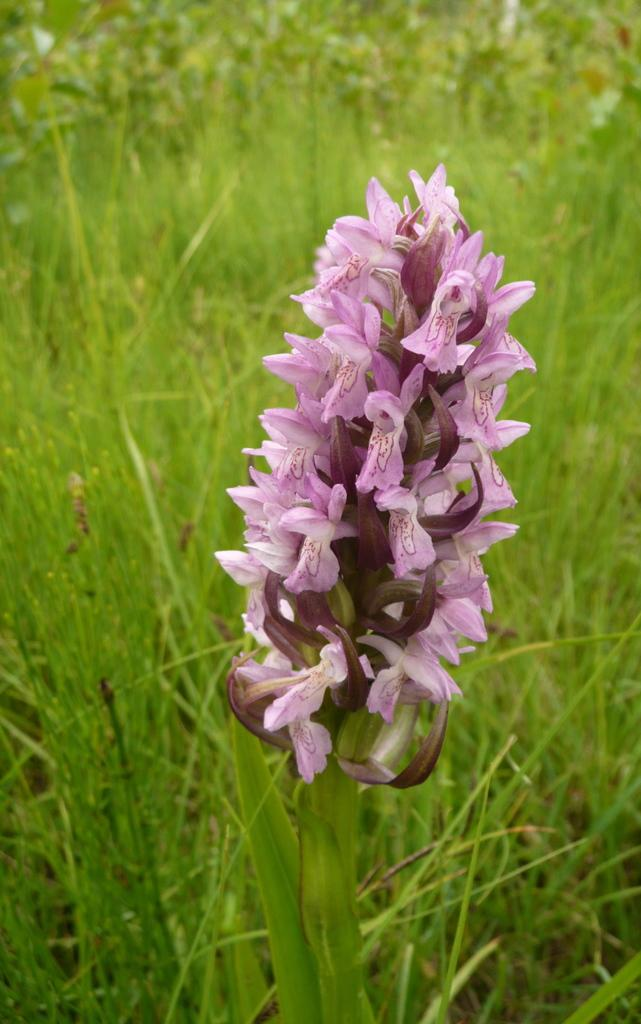What type of living organisms can be seen in the image? There are flowers on a plant in the image. Where are the plants located in the image? There are plants on the ground in the image. What type of frame is visible around the flowers in the image? There is no frame visible in the image. 